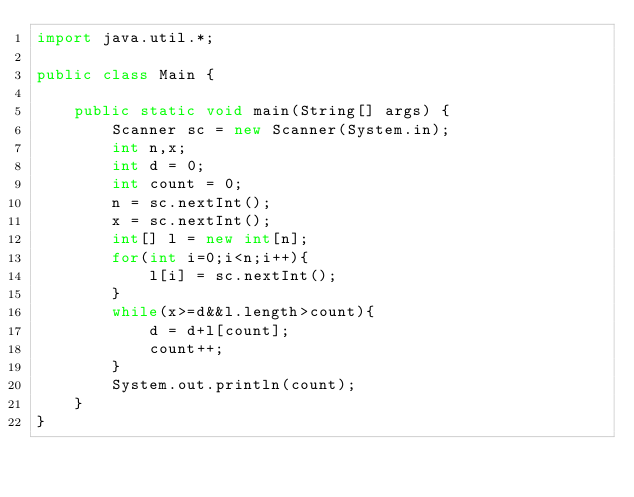<code> <loc_0><loc_0><loc_500><loc_500><_Java_>import java.util.*;

public class Main {

    public static void main(String[] args) {
        Scanner sc = new Scanner(System.in);
        int n,x;
        int d = 0;
        int count = 0;
        n = sc.nextInt();
        x = sc.nextInt();
        int[] l = new int[n];
        for(int i=0;i<n;i++){
            l[i] = sc.nextInt();
        }
        while(x>=d&&l.length>count){
            d = d+l[count];
            count++;
        }
        System.out.println(count);
    }
}</code> 